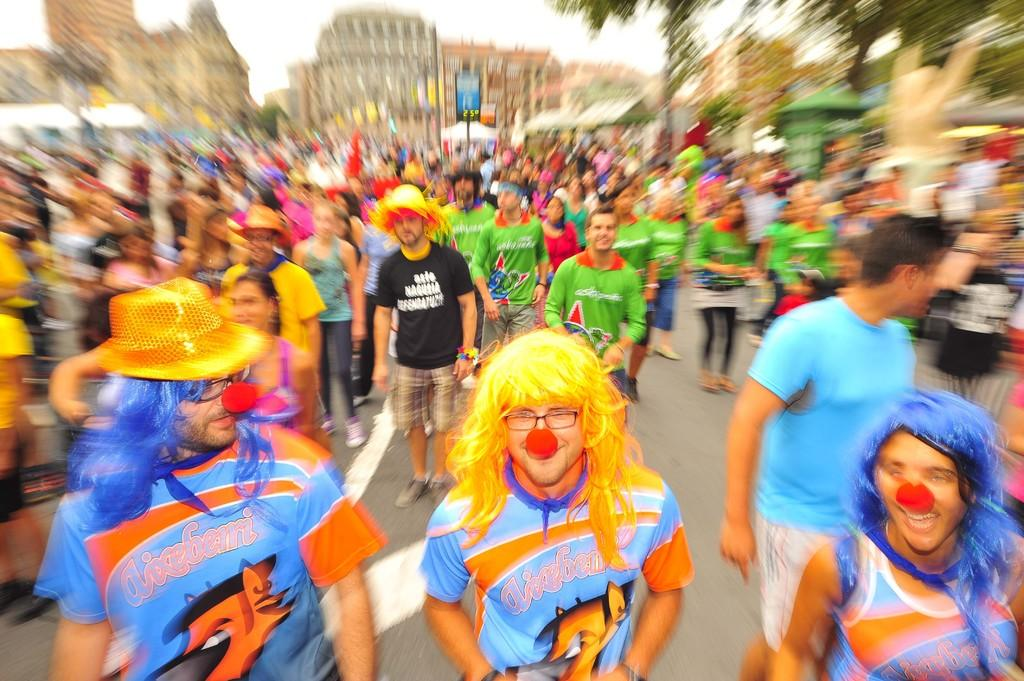How many people are in the group depicted in the image? There is a group of people in the image, but the exact number is not specified. What can be observed about some of the people in the group? Some people in the group are wearing spectacles. What can be seen in the background of the image? There are trees and buildings in the background of the image. What type of bread is being folded by the people in the image? There is no bread or folding activity present in the image. How many yams are visible in the image? There are no yams present in the image. 